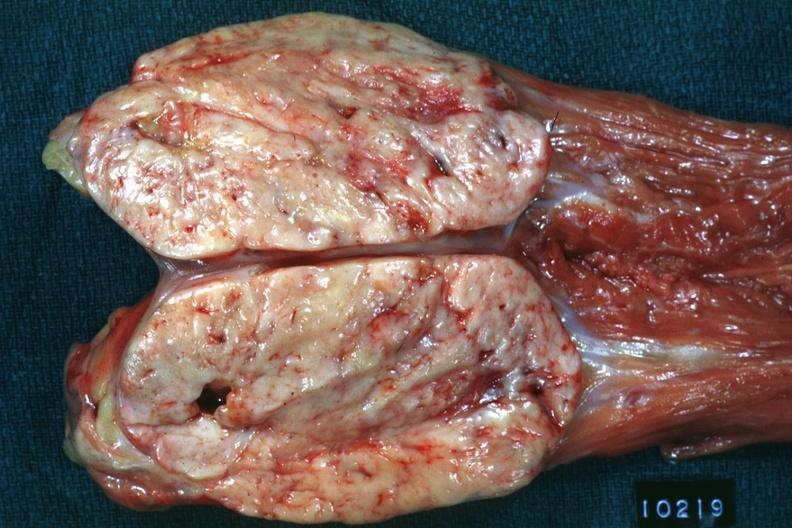does this image show opened muscle probably psoas natural color large ovoid typical sarcoma?
Answer the question using a single word or phrase. Yes 